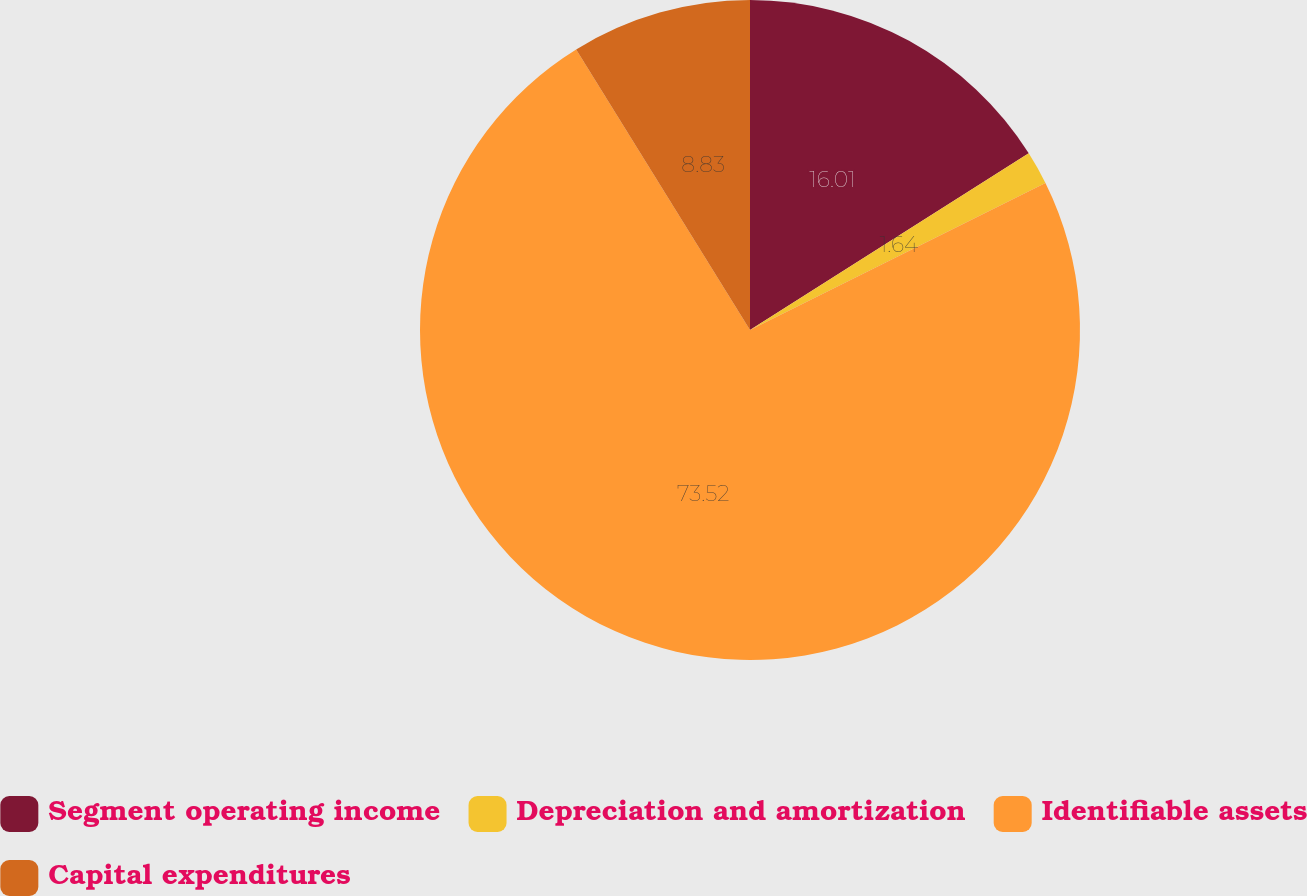Convert chart to OTSL. <chart><loc_0><loc_0><loc_500><loc_500><pie_chart><fcel>Segment operating income<fcel>Depreciation and amortization<fcel>Identifiable assets<fcel>Capital expenditures<nl><fcel>16.01%<fcel>1.64%<fcel>73.52%<fcel>8.83%<nl></chart> 